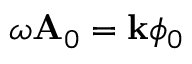<formula> <loc_0><loc_0><loc_500><loc_500>\omega A _ { 0 } = k \phi _ { 0 }</formula> 